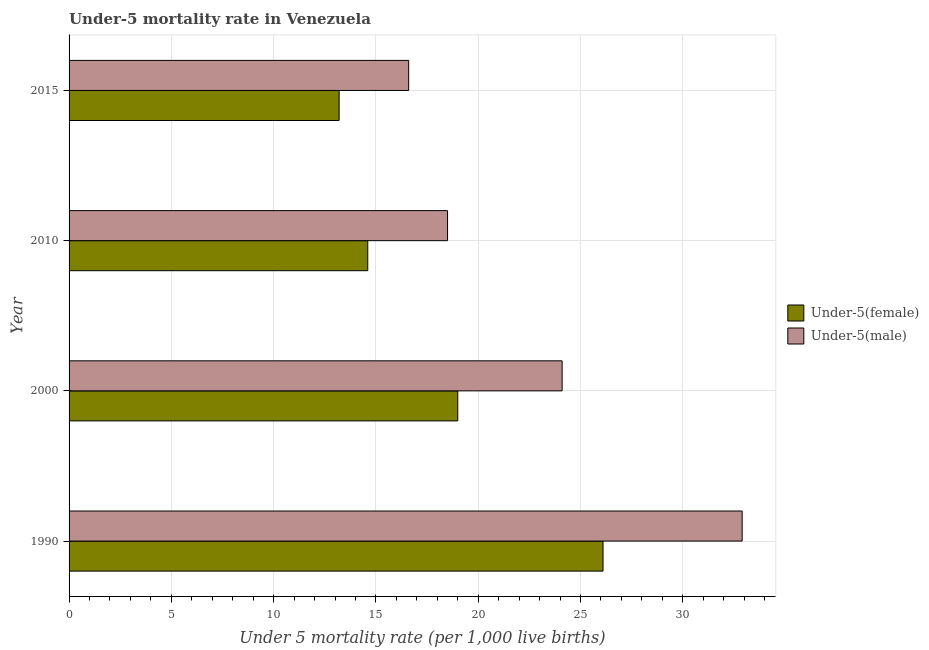How many different coloured bars are there?
Your answer should be compact. 2. How many bars are there on the 3rd tick from the top?
Provide a short and direct response. 2. How many bars are there on the 3rd tick from the bottom?
Provide a succinct answer. 2. In how many cases, is the number of bars for a given year not equal to the number of legend labels?
Your response must be concise. 0. What is the under-5 male mortality rate in 2000?
Keep it short and to the point. 24.1. Across all years, what is the maximum under-5 male mortality rate?
Ensure brevity in your answer.  32.9. In which year was the under-5 male mortality rate maximum?
Your response must be concise. 1990. In which year was the under-5 female mortality rate minimum?
Your answer should be compact. 2015. What is the total under-5 female mortality rate in the graph?
Your response must be concise. 72.9. What is the difference between the under-5 female mortality rate in 2010 and the under-5 male mortality rate in 2015?
Provide a succinct answer. -2. What is the average under-5 male mortality rate per year?
Provide a short and direct response. 23.02. In the year 2010, what is the difference between the under-5 female mortality rate and under-5 male mortality rate?
Offer a very short reply. -3.9. In how many years, is the under-5 female mortality rate greater than 2 ?
Your answer should be very brief. 4. What is the ratio of the under-5 male mortality rate in 1990 to that in 2010?
Give a very brief answer. 1.78. Is the under-5 male mortality rate in 1990 less than that in 2015?
Your response must be concise. No. Is the difference between the under-5 male mortality rate in 2010 and 2015 greater than the difference between the under-5 female mortality rate in 2010 and 2015?
Your response must be concise. Yes. In how many years, is the under-5 female mortality rate greater than the average under-5 female mortality rate taken over all years?
Your answer should be very brief. 2. Is the sum of the under-5 female mortality rate in 2010 and 2015 greater than the maximum under-5 male mortality rate across all years?
Make the answer very short. No. What does the 1st bar from the top in 2010 represents?
Give a very brief answer. Under-5(male). What does the 1st bar from the bottom in 2010 represents?
Your answer should be very brief. Under-5(female). Are all the bars in the graph horizontal?
Keep it short and to the point. Yes. Are the values on the major ticks of X-axis written in scientific E-notation?
Offer a terse response. No. How are the legend labels stacked?
Offer a terse response. Vertical. What is the title of the graph?
Make the answer very short. Under-5 mortality rate in Venezuela. Does "Electricity" appear as one of the legend labels in the graph?
Offer a terse response. No. What is the label or title of the X-axis?
Offer a very short reply. Under 5 mortality rate (per 1,0 live births). What is the Under 5 mortality rate (per 1,000 live births) of Under-5(female) in 1990?
Keep it short and to the point. 26.1. What is the Under 5 mortality rate (per 1,000 live births) in Under-5(male) in 1990?
Offer a terse response. 32.9. What is the Under 5 mortality rate (per 1,000 live births) of Under-5(female) in 2000?
Make the answer very short. 19. What is the Under 5 mortality rate (per 1,000 live births) of Under-5(male) in 2000?
Your answer should be very brief. 24.1. What is the Under 5 mortality rate (per 1,000 live births) in Under-5(male) in 2010?
Keep it short and to the point. 18.5. What is the Under 5 mortality rate (per 1,000 live births) in Under-5(female) in 2015?
Offer a terse response. 13.2. What is the Under 5 mortality rate (per 1,000 live births) of Under-5(male) in 2015?
Your response must be concise. 16.6. Across all years, what is the maximum Under 5 mortality rate (per 1,000 live births) in Under-5(female)?
Your answer should be very brief. 26.1. Across all years, what is the maximum Under 5 mortality rate (per 1,000 live births) of Under-5(male)?
Keep it short and to the point. 32.9. Across all years, what is the minimum Under 5 mortality rate (per 1,000 live births) in Under-5(male)?
Keep it short and to the point. 16.6. What is the total Under 5 mortality rate (per 1,000 live births) of Under-5(female) in the graph?
Your answer should be compact. 72.9. What is the total Under 5 mortality rate (per 1,000 live births) in Under-5(male) in the graph?
Ensure brevity in your answer.  92.1. What is the difference between the Under 5 mortality rate (per 1,000 live births) in Under-5(female) in 1990 and that in 2000?
Ensure brevity in your answer.  7.1. What is the difference between the Under 5 mortality rate (per 1,000 live births) in Under-5(female) in 1990 and that in 2010?
Your response must be concise. 11.5. What is the difference between the Under 5 mortality rate (per 1,000 live births) in Under-5(female) in 2000 and that in 2010?
Provide a short and direct response. 4.4. What is the difference between the Under 5 mortality rate (per 1,000 live births) of Under-5(male) in 2000 and that in 2010?
Offer a terse response. 5.6. What is the difference between the Under 5 mortality rate (per 1,000 live births) in Under-5(male) in 2000 and that in 2015?
Give a very brief answer. 7.5. What is the difference between the Under 5 mortality rate (per 1,000 live births) of Under-5(male) in 2010 and that in 2015?
Your response must be concise. 1.9. What is the difference between the Under 5 mortality rate (per 1,000 live births) of Under-5(female) in 1990 and the Under 5 mortality rate (per 1,000 live births) of Under-5(male) in 2010?
Your answer should be very brief. 7.6. What is the average Under 5 mortality rate (per 1,000 live births) in Under-5(female) per year?
Ensure brevity in your answer.  18.23. What is the average Under 5 mortality rate (per 1,000 live births) of Under-5(male) per year?
Ensure brevity in your answer.  23.02. In the year 1990, what is the difference between the Under 5 mortality rate (per 1,000 live births) in Under-5(female) and Under 5 mortality rate (per 1,000 live births) in Under-5(male)?
Offer a very short reply. -6.8. In the year 2000, what is the difference between the Under 5 mortality rate (per 1,000 live births) in Under-5(female) and Under 5 mortality rate (per 1,000 live births) in Under-5(male)?
Provide a short and direct response. -5.1. In the year 2010, what is the difference between the Under 5 mortality rate (per 1,000 live births) in Under-5(female) and Under 5 mortality rate (per 1,000 live births) in Under-5(male)?
Provide a short and direct response. -3.9. What is the ratio of the Under 5 mortality rate (per 1,000 live births) of Under-5(female) in 1990 to that in 2000?
Offer a terse response. 1.37. What is the ratio of the Under 5 mortality rate (per 1,000 live births) of Under-5(male) in 1990 to that in 2000?
Your response must be concise. 1.37. What is the ratio of the Under 5 mortality rate (per 1,000 live births) in Under-5(female) in 1990 to that in 2010?
Ensure brevity in your answer.  1.79. What is the ratio of the Under 5 mortality rate (per 1,000 live births) of Under-5(male) in 1990 to that in 2010?
Make the answer very short. 1.78. What is the ratio of the Under 5 mortality rate (per 1,000 live births) of Under-5(female) in 1990 to that in 2015?
Provide a short and direct response. 1.98. What is the ratio of the Under 5 mortality rate (per 1,000 live births) of Under-5(male) in 1990 to that in 2015?
Your answer should be compact. 1.98. What is the ratio of the Under 5 mortality rate (per 1,000 live births) in Under-5(female) in 2000 to that in 2010?
Offer a very short reply. 1.3. What is the ratio of the Under 5 mortality rate (per 1,000 live births) of Under-5(male) in 2000 to that in 2010?
Keep it short and to the point. 1.3. What is the ratio of the Under 5 mortality rate (per 1,000 live births) in Under-5(female) in 2000 to that in 2015?
Give a very brief answer. 1.44. What is the ratio of the Under 5 mortality rate (per 1,000 live births) of Under-5(male) in 2000 to that in 2015?
Ensure brevity in your answer.  1.45. What is the ratio of the Under 5 mortality rate (per 1,000 live births) of Under-5(female) in 2010 to that in 2015?
Make the answer very short. 1.11. What is the ratio of the Under 5 mortality rate (per 1,000 live births) in Under-5(male) in 2010 to that in 2015?
Provide a succinct answer. 1.11. What is the difference between the highest and the second highest Under 5 mortality rate (per 1,000 live births) of Under-5(female)?
Give a very brief answer. 7.1. What is the difference between the highest and the second highest Under 5 mortality rate (per 1,000 live births) of Under-5(male)?
Your response must be concise. 8.8. 